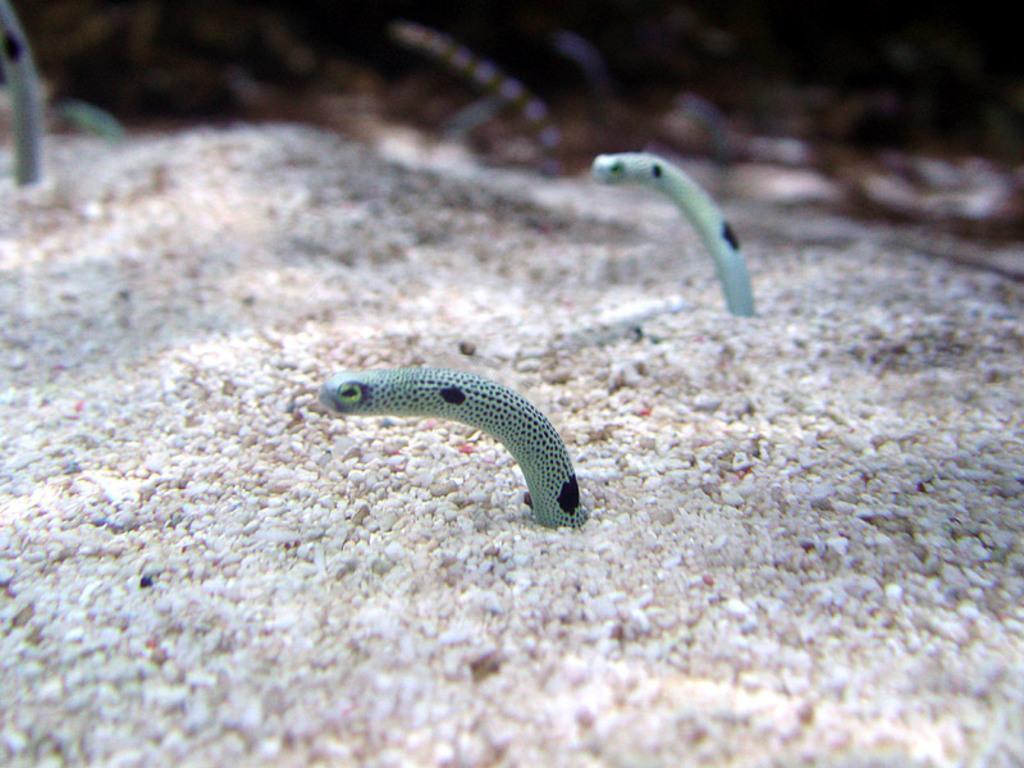Describe this image in one or two sentences. In this image, we can see snakes. Top of the image, there is a blur view. Here we can see stones. 